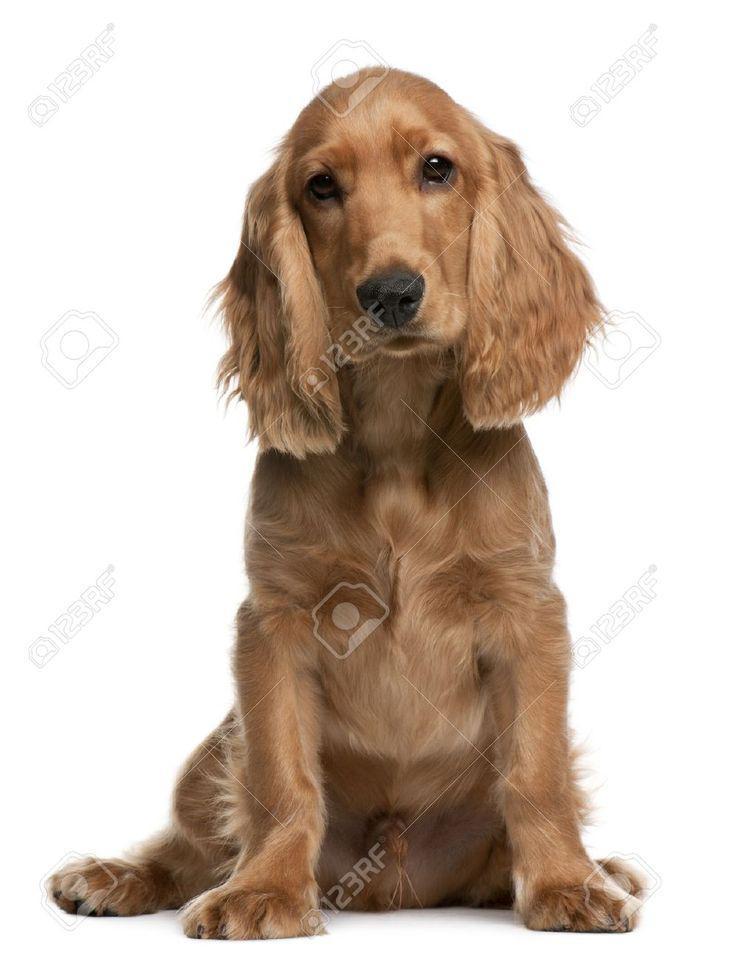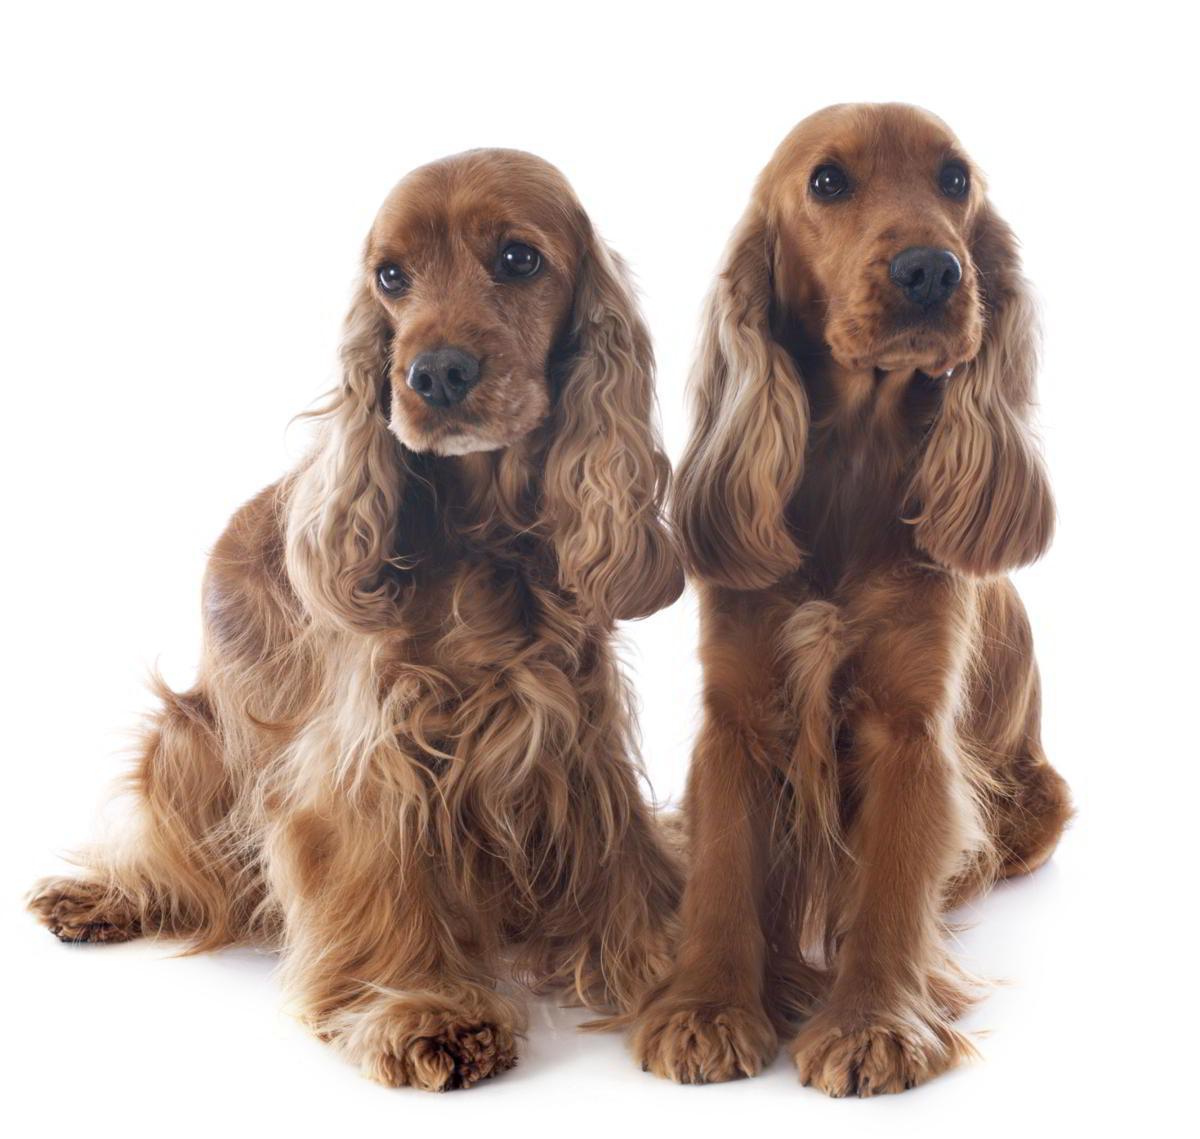The first image is the image on the left, the second image is the image on the right. Given the left and right images, does the statement "One dog is sitting and one is laying down." hold true? Answer yes or no. No. The first image is the image on the left, the second image is the image on the right. Evaluate the accuracy of this statement regarding the images: "One image contains a 'ginger' cocker spaniel sitting upright, and the other contains a 'ginger' cocker spaniel in a reclining pose.". Is it true? Answer yes or no. No. 